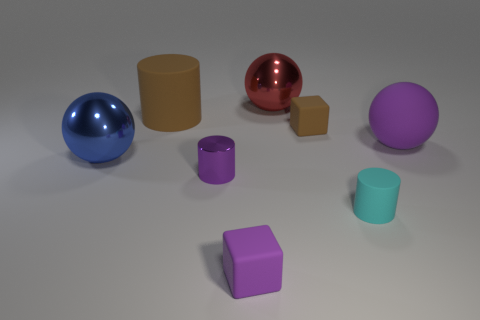Add 1 large purple matte things. How many objects exist? 9 Subtract all cubes. How many objects are left? 6 Subtract 1 cyan cylinders. How many objects are left? 7 Subtract all large blue objects. Subtract all big matte cylinders. How many objects are left? 6 Add 6 blue spheres. How many blue spheres are left? 7 Add 6 large objects. How many large objects exist? 10 